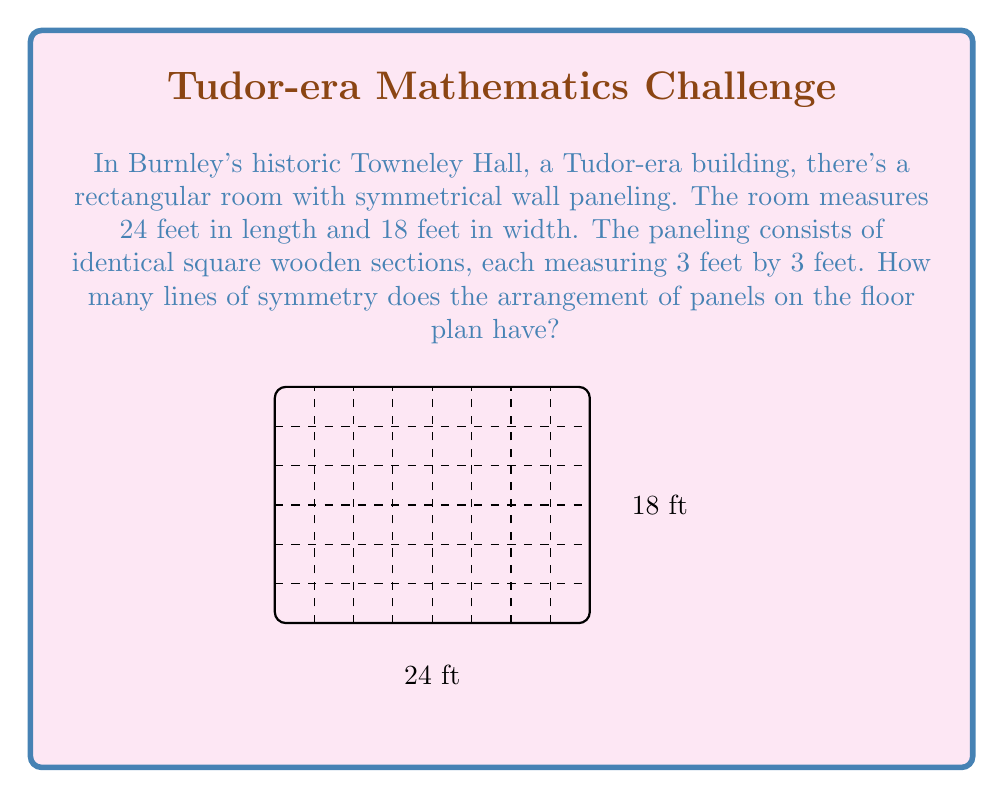What is the answer to this math problem? Let's approach this step-by-step:

1) First, we need to determine the number of panels along each dimension:
   - Length: $24 \div 3 = 8$ panels
   - Width: $18 \div 3 = 6$ panels

2) The floor plan now represents a grid of $8 \times 6$ squares.

3) Lines of symmetry in a rectangle can be:
   a) Vertical (splitting the length)
   b) Horizontal (splitting the width)
   c) Diagonal (if the rectangle is a square, which this is not)

4) For vertical lines of symmetry:
   - The number of panels lengthwise is even (8)
   - There will be a line of symmetry between the 4th and 5th panels
   - Total vertical lines: 1

5) For horizontal lines of symmetry:
   - The number of panels widthwise is even (6)
   - There will be a line of symmetry between the 3rd and 4th panels
   - Total horizontal lines: 1

6) There are no diagonal lines of symmetry as the room is not square.

7) Total lines of symmetry = Vertical + Horizontal = $1 + 1 = 2$
Answer: 2 